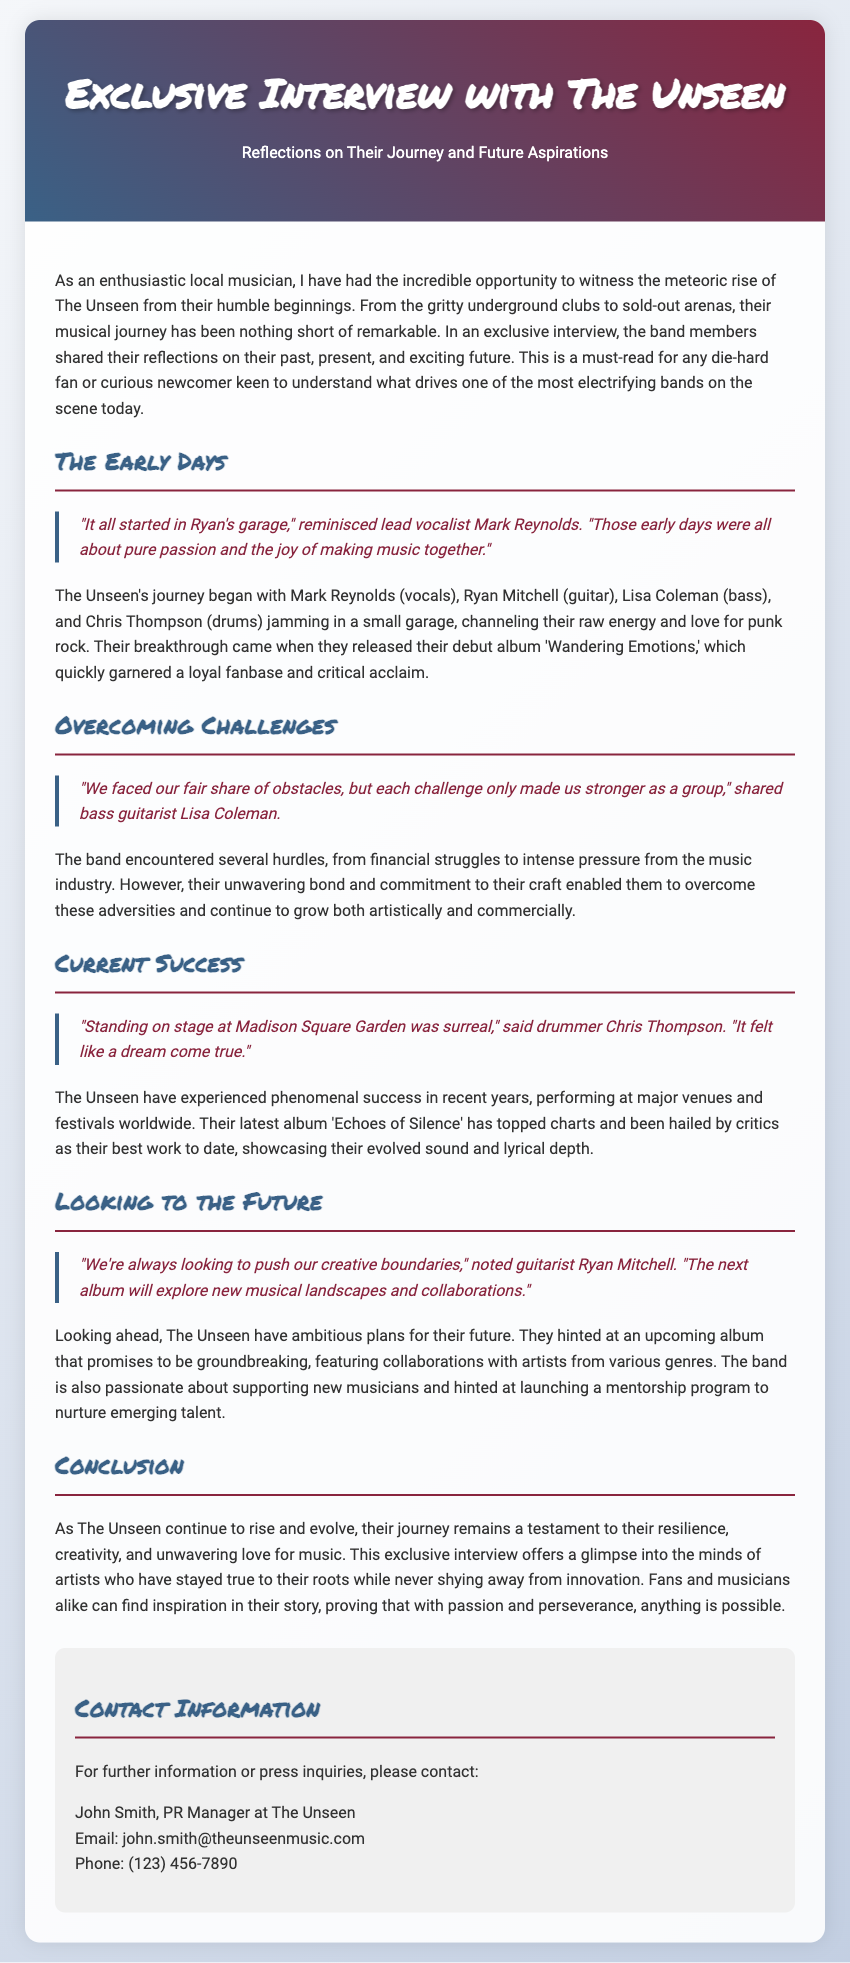What is the title of the interview? The title is the main heading at the top of the document, which introduces the subject matter of the press release.
Answer: Exclusive Interview with The Unseen Who is the lead vocalist of The Unseen? The lead vocalist is mentioned in the section discussing the early days of the band, reflecting on their beginnings.
Answer: Mark Reynolds What was the name of The Unseen's debut album? The debut album is specified in the content section recounting the band's rise to fame.
Answer: Wandering Emotions How did Chris Thompson describe performing at Madison Square Garden? This quote reflects the drummer's feelings regarding a significant performance in the band's career.
Answer: surreal What future plans did Ryan Mitchell mention? This question addresses the band's ambitions for their music and creative direction as outlined in the document.
Answer: new musical landscapes and collaborations How many members are in The Unseen? This is determined by counting the members listed in the early days section of the document.
Answer: four What genre does The Unseen's music primarily represent? The genre is inferred from the context of their beginnings and style mentioned in the document.
Answer: punk rock What is the title of The Unseen's latest album? This is specified in the section detailing their current success and artistic evolution.
Answer: Echoes of Silence What type of program did The Unseen hint at launching? This relates to their intentions for supporting new musicians as indicated in the future aspirations section.
Answer: mentorship program 